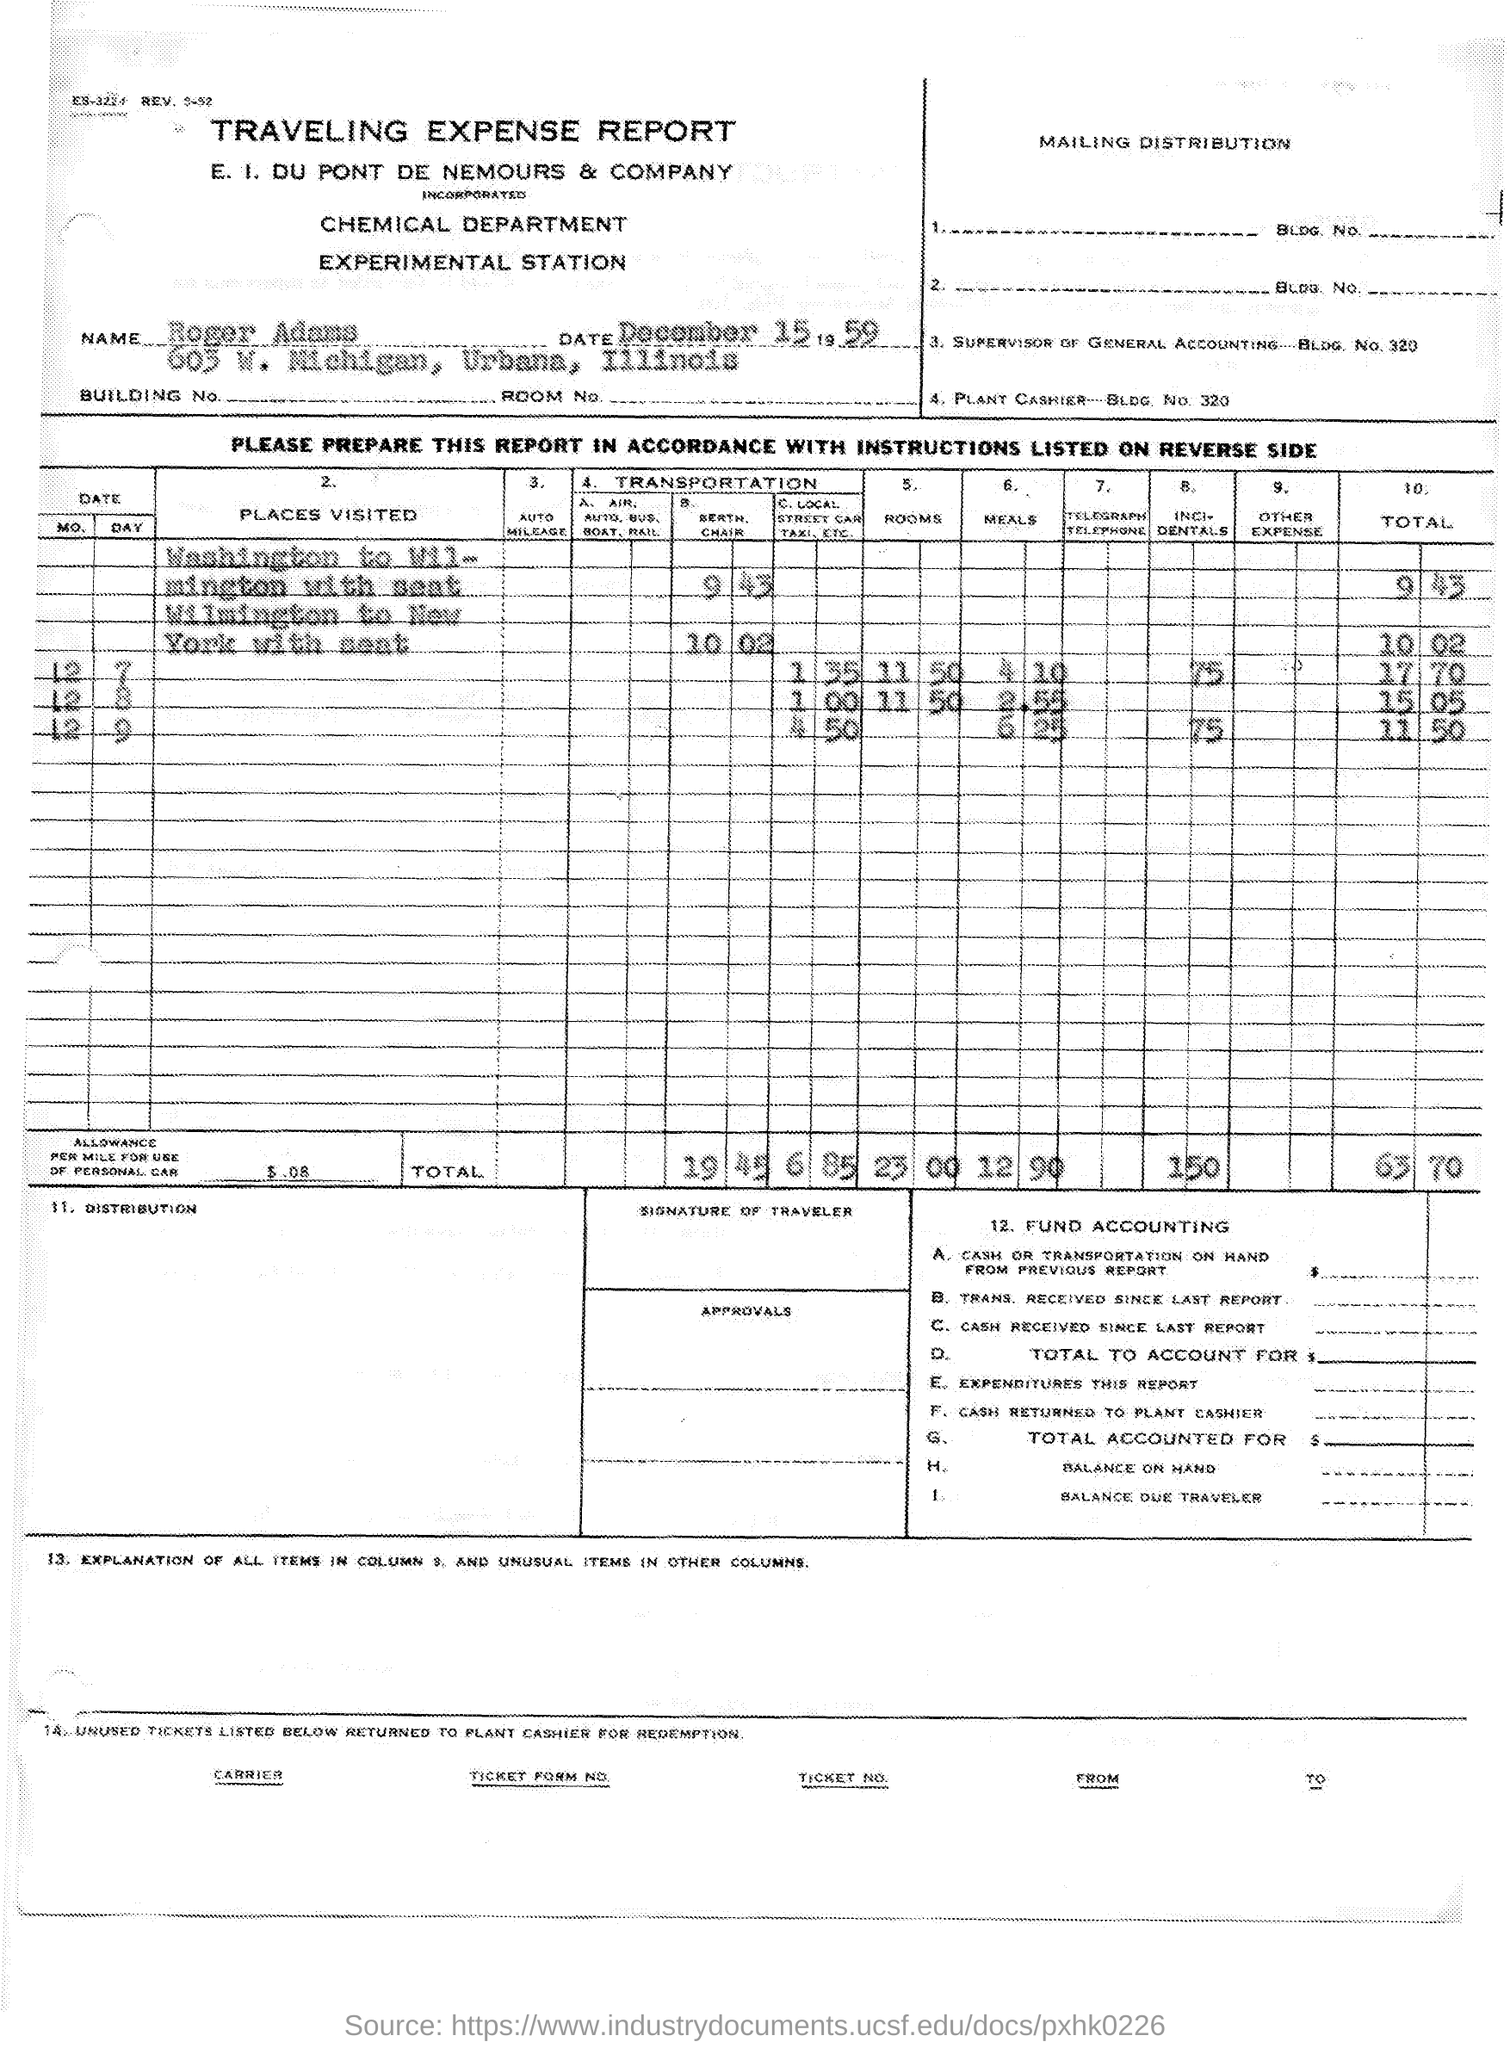What is the document about?
Offer a very short reply. TRAVELING EXPENSE REPORT. What is the date given?
Your answer should be compact. December 15 1959. What is the total amount?
Give a very brief answer. 63 70. 